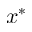<formula> <loc_0><loc_0><loc_500><loc_500>x ^ { * }</formula> 